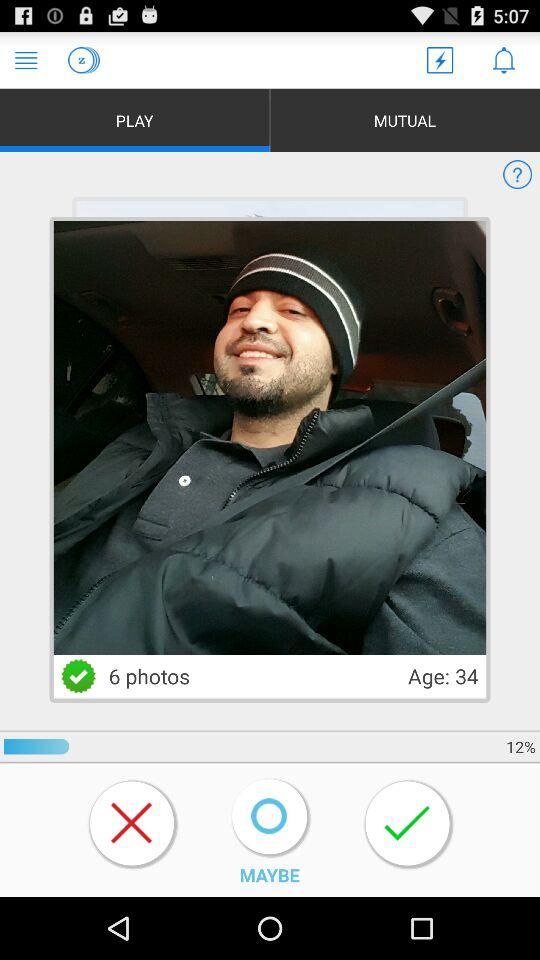What is the age of the user? The age of the user is 34. 